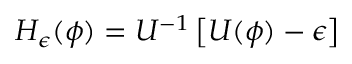Convert formula to latex. <formula><loc_0><loc_0><loc_500><loc_500>{ H } _ { \epsilon } ( \phi ) = { U } ^ { - 1 } \left [ { U } ( \phi ) - \epsilon \right ]</formula> 